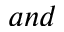<formula> <loc_0><loc_0><loc_500><loc_500>a n d</formula> 